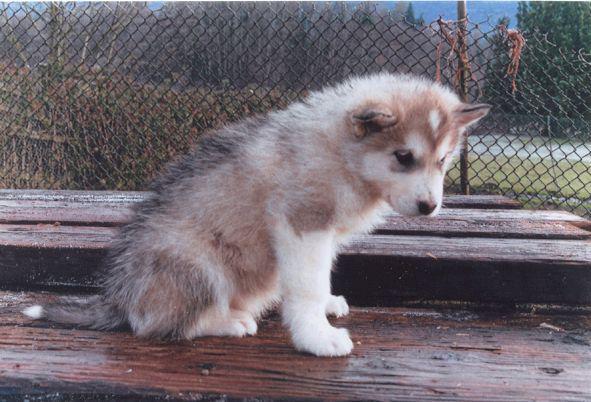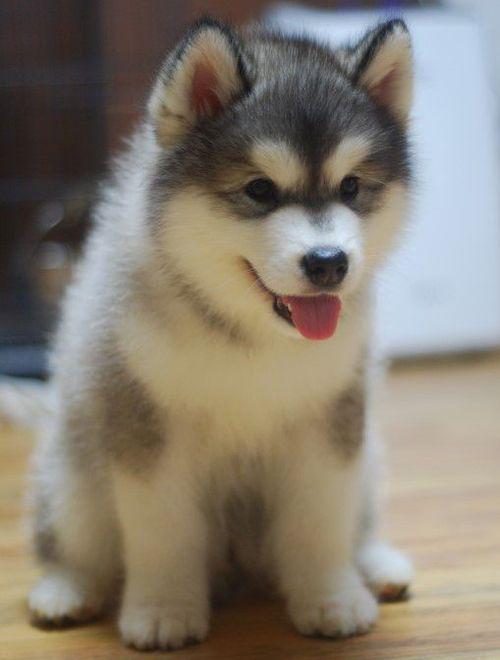The first image is the image on the left, the second image is the image on the right. For the images displayed, is the sentence "Exactly one dog is sitting." factually correct? Answer yes or no. No. The first image is the image on the left, the second image is the image on the right. Evaluate the accuracy of this statement regarding the images: "The left image features a puppy sitting upright in profile, and the right image features a grey-and-white husky facing forward.". Is it true? Answer yes or no. Yes. 